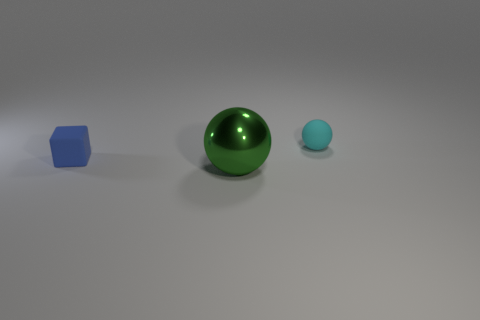What is the material of the small object that is to the left of the small cyan object on the right side of the metal thing?
Your answer should be compact. Rubber. How many other things are the same shape as the tiny cyan matte object?
Your response must be concise. 1. Do the matte thing that is to the left of the green ball and the small rubber thing that is behind the cube have the same shape?
Give a very brief answer. No. Are there any other things that are made of the same material as the cyan sphere?
Provide a succinct answer. Yes. What is the material of the green object?
Make the answer very short. Metal. What material is the tiny object that is on the left side of the green ball?
Your answer should be compact. Rubber. Is there any other thing that is the same color as the tiny block?
Offer a terse response. No. The object that is the same material as the block is what size?
Give a very brief answer. Small. What number of big things are cyan spheres or matte blocks?
Keep it short and to the point. 0. What is the size of the thing in front of the tiny matte thing in front of the object that is behind the blue rubber thing?
Ensure brevity in your answer.  Large. 